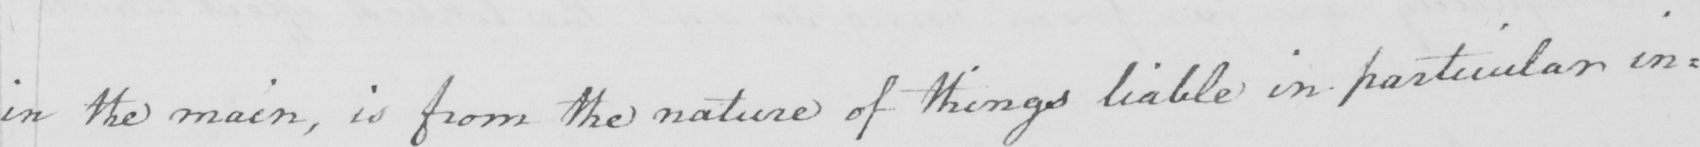What is written in this line of handwriting? in the main , is from the nature of things liable in particular in= 